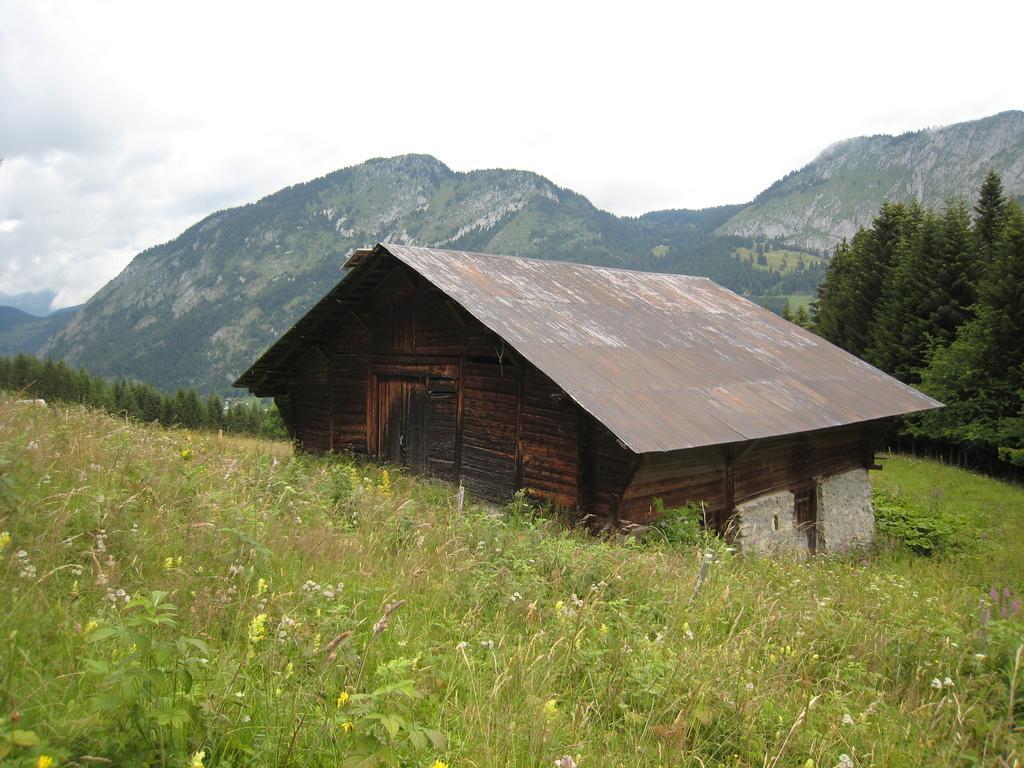Could you give a brief overview of what you see in this image? In this picture there is a wooden house in the center of the image, there is greenery around the area of the image. 